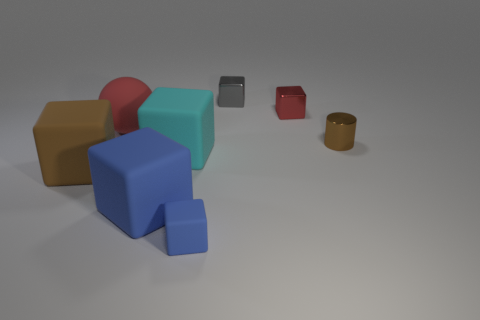There is a tiny red thing that is the same shape as the big blue object; what is its material?
Your response must be concise. Metal. How many things are either blue cubes in front of the big cyan thing or large blue rubber cubes?
Keep it short and to the point. 2. What shape is the large red object that is made of the same material as the big brown object?
Keep it short and to the point. Sphere. How many large brown rubber objects have the same shape as the large blue rubber thing?
Keep it short and to the point. 1. What is the large blue block made of?
Give a very brief answer. Rubber. Is the color of the ball the same as the small metal block that is to the right of the small gray metal thing?
Keep it short and to the point. Yes. How many cylinders are either tiny red objects or small blue objects?
Provide a succinct answer. 0. The object that is behind the small red shiny block is what color?
Provide a short and direct response. Gray. The object that is the same color as the small metal cylinder is what shape?
Offer a very short reply. Cube. What number of red matte balls are the same size as the cyan rubber thing?
Ensure brevity in your answer.  1. 